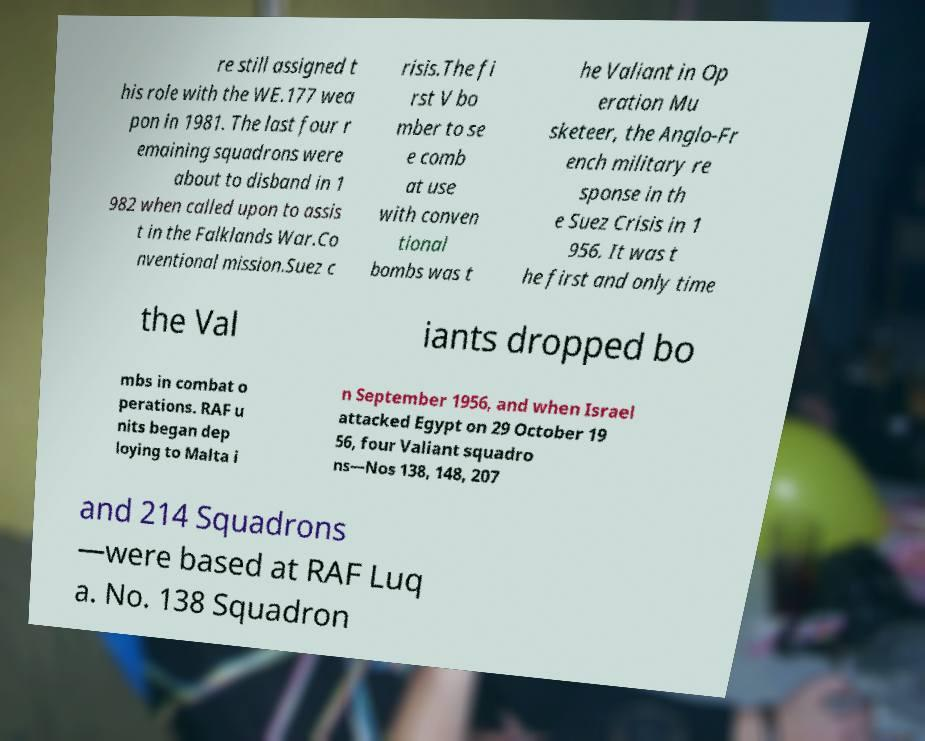I need the written content from this picture converted into text. Can you do that? re still assigned t his role with the WE.177 wea pon in 1981. The last four r emaining squadrons were about to disband in 1 982 when called upon to assis t in the Falklands War.Co nventional mission.Suez c risis.The fi rst V bo mber to se e comb at use with conven tional bombs was t he Valiant in Op eration Mu sketeer, the Anglo-Fr ench military re sponse in th e Suez Crisis in 1 956. It was t he first and only time the Val iants dropped bo mbs in combat o perations. RAF u nits began dep loying to Malta i n September 1956, and when Israel attacked Egypt on 29 October 19 56, four Valiant squadro ns—Nos 138, 148, 207 and 214 Squadrons —were based at RAF Luq a. No. 138 Squadron 